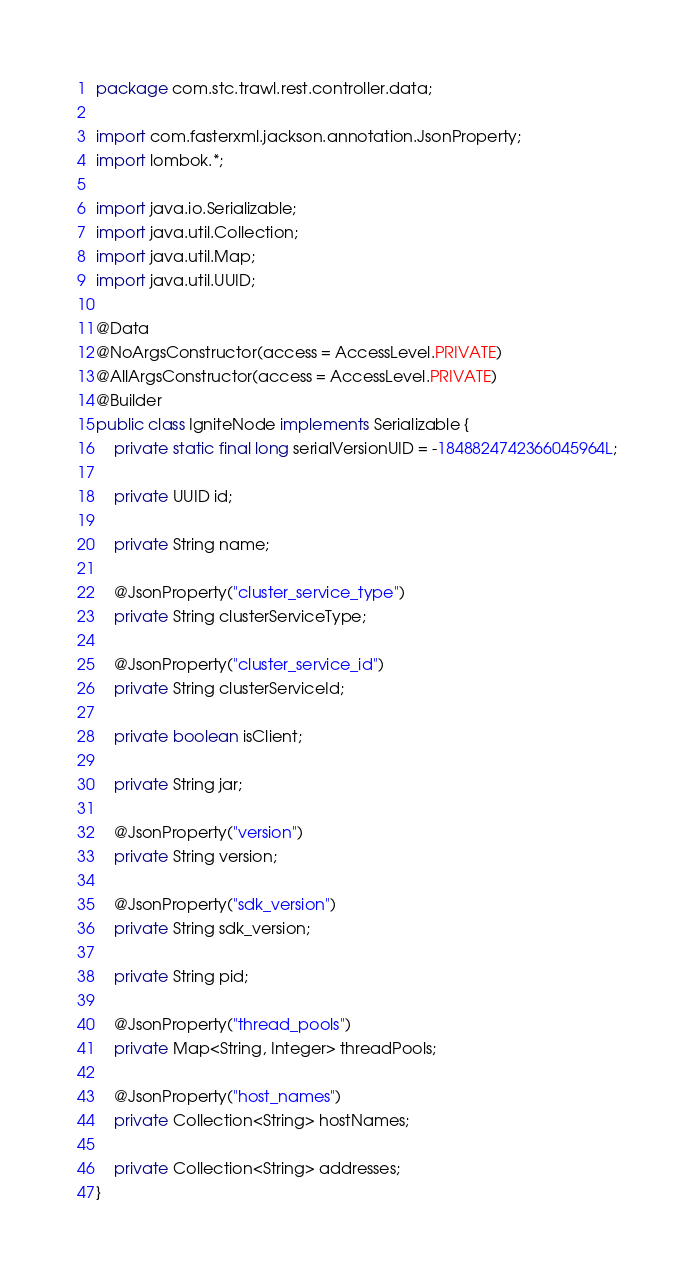<code> <loc_0><loc_0><loc_500><loc_500><_Java_>package com.stc.trawl.rest.controller.data;

import com.fasterxml.jackson.annotation.JsonProperty;
import lombok.*;

import java.io.Serializable;
import java.util.Collection;
import java.util.Map;
import java.util.UUID;

@Data
@NoArgsConstructor(access = AccessLevel.PRIVATE)
@AllArgsConstructor(access = AccessLevel.PRIVATE)
@Builder
public class IgniteNode implements Serializable {
    private static final long serialVersionUID = -1848824742366045964L;

    private UUID id;

    private String name;

    @JsonProperty("cluster_service_type")
    private String clusterServiceType;

    @JsonProperty("cluster_service_id")
    private String clusterServiceId;

    private boolean isClient;

    private String jar;

    @JsonProperty("version")
    private String version;

    @JsonProperty("sdk_version")
    private String sdk_version;

    private String pid;

    @JsonProperty("thread_pools")
    private Map<String, Integer> threadPools;

    @JsonProperty("host_names")
    private Collection<String> hostNames;

    private Collection<String> addresses;
}
</code> 